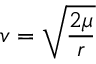<formula> <loc_0><loc_0><loc_500><loc_500>v = { \sqrt { \frac { 2 \mu } { r } } }</formula> 